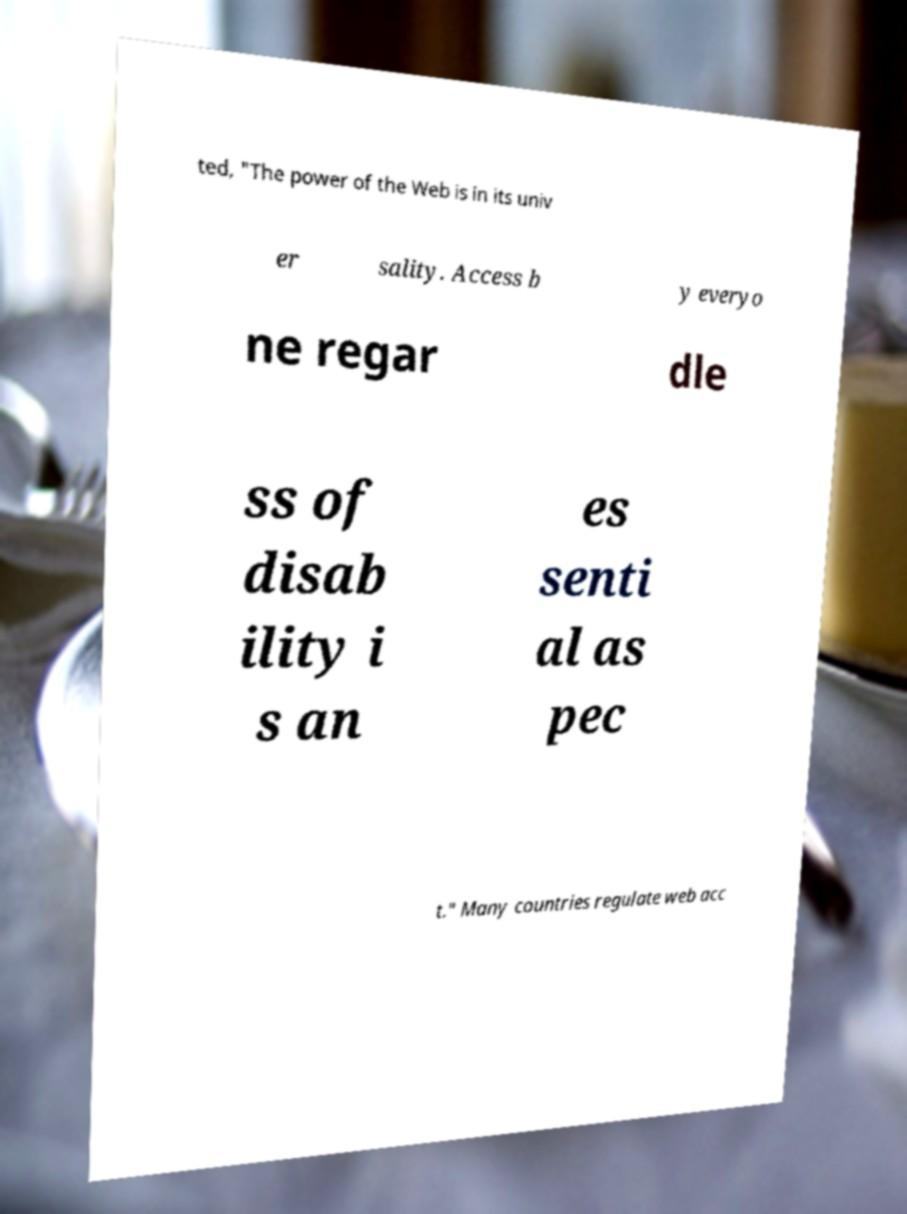Could you extract and type out the text from this image? ted, "The power of the Web is in its univ er sality. Access b y everyo ne regar dle ss of disab ility i s an es senti al as pec t." Many countries regulate web acc 